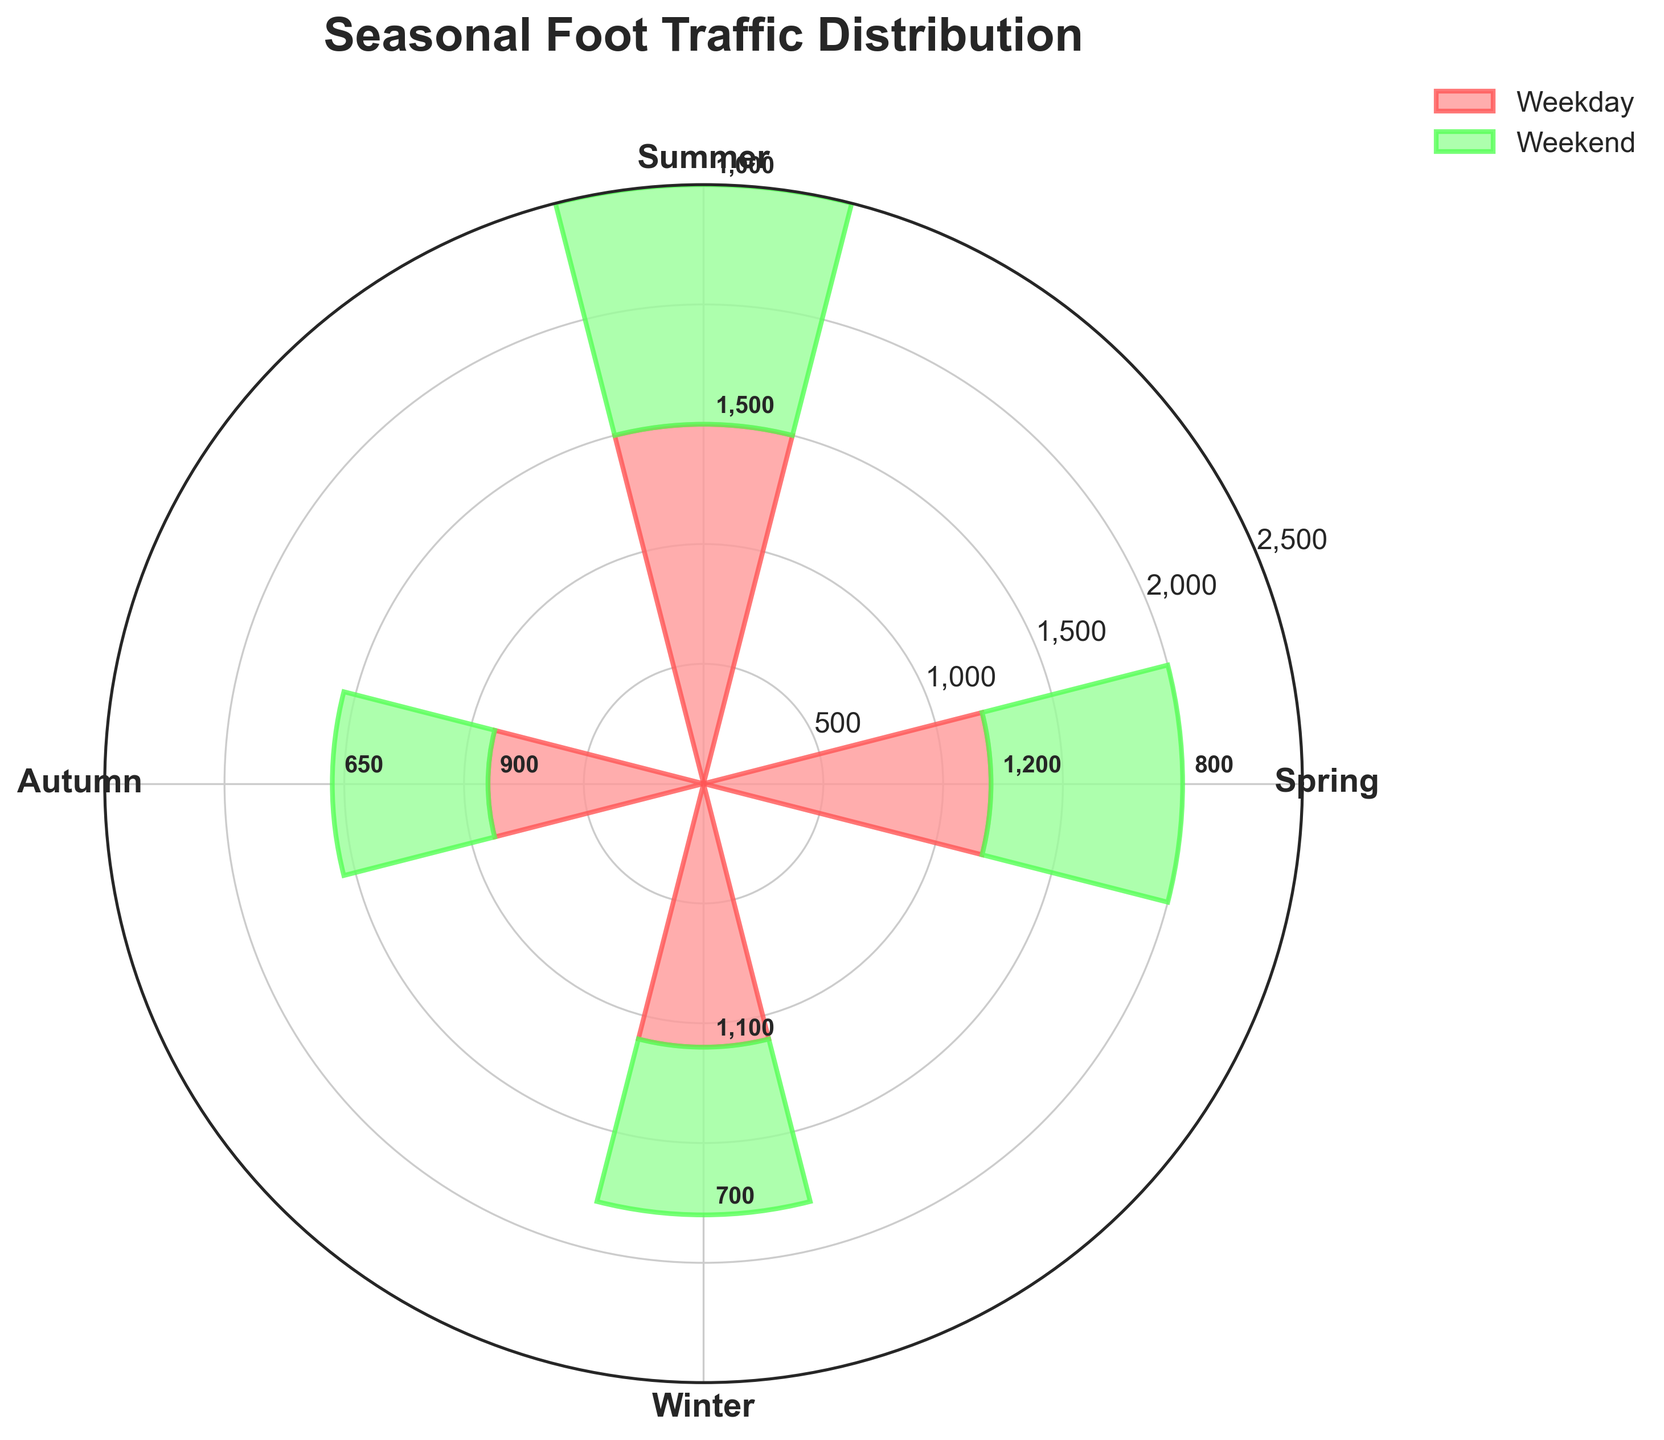What is the title of the chart? The title of the chart is usually placed at the top center of the figure, making it easily identifiable. In this case, it reads: 'Seasonal Foot Traffic Distribution'.
Answer: Seasonal Foot Traffic Distribution Which season has the highest weekday foot traffic? To find the season with the highest weekday foot traffic, look at the height of the bars in the chart labeled 'Weekday'. Summer has the tallest bar for weekdays, indicating the highest foot traffic.
Answer: Summer How does the weekend foot traffic in Winter compare to Spring? Compare the height of the 'Weekend' bars for Winter and Spring. Winter's bar is slightly shorter than Spring's, indicating that Winter has lower weekend foot traffic compared to Spring.
Answer: Winter has lower weekend foot traffic What is the total foot traffic for Summer? Add the foot traffic values for both weekdays and weekends in Summer. Weekday traffic is 1500, and weekend traffic is 1000. So, total foot traffic for Summer is 1500 + 1000.
Answer: 2500 Which season has the lowest total foot traffic? Sum the weekday and weekend foot traffic for each season and compare. Winter has the lowest total, with 1100 (weekday) + 700 (weekend) = 1800.
Answer: Winter What is the combined foot traffic for weekends across all seasons? Add the weekend traffic values for Spring, Summer, Autumn, and Winter. Weekend traffic is 800 (Spring) + 1000 (Summer) + 650 (Autumn) + 700 (Winter).
Answer: 3150 How much more foot traffic does the store get on weekdays in Summer compared to Autumn? Subtract the weekday foot traffic for Autumn from that of Summer. Summer has 1500 and Autumn has 900, so 1500 - 900.
Answer: 600 What is the average weekday foot traffic across all seasons? Add the weekday foot traffic for each season and divide by the number of seasons. The values are 1200 (Spring) + 1500 (Summer) + 900 (Autumn) + 1100 (Winter). The average is (1200 + 1500 + 900 + 1100) / 4.
Answer: 1175 During which season is the difference between weekday and weekend foot traffic the smallest? Calculate the differences for each season: Spring (1200 - 800 = 400), Summer (1500 - 1000 = 500), Autumn (900 - 650 = 250), Winter (1100 - 700 = 400). The smallest difference is in Autumn.
Answer: Autumn What is the foot traffic on weekends in Spring and Autumn combined? Add the weekend foot traffic for Spring and Autumn. The values are 800 (Spring) and 650 (Autumn).
Answer: 1450 